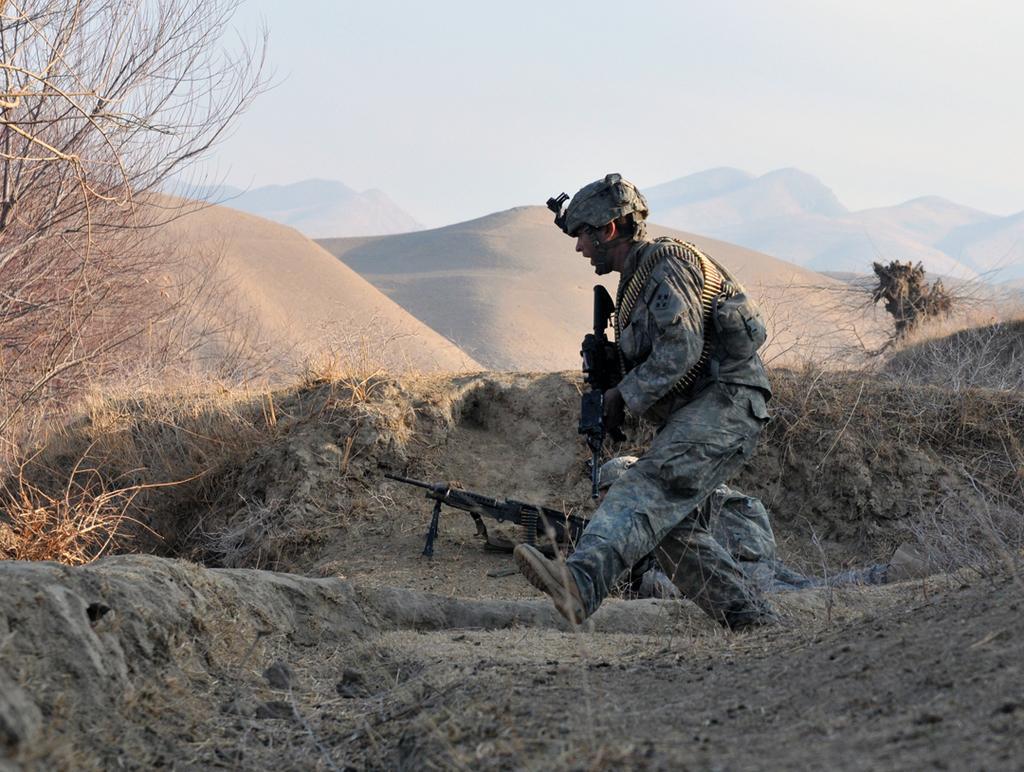Please provide a concise description of this image. In this image, we can see people wearing uniforms and helmets and holding guns. In the background, there are hills, rocks and trees. At the bottom, there is ground and at the top, there is sky. 